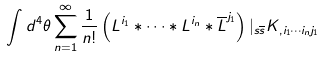<formula> <loc_0><loc_0><loc_500><loc_500>\int d ^ { 4 } \theta \sum _ { n = 1 } ^ { \infty } \frac { 1 } { n ! } \left ( L ^ { i _ { 1 } } \ast \dots \ast L ^ { i _ { n } } \ast \overline { L } ^ { j _ { 1 } } \right ) | _ { s \overline { s } } K _ { , i _ { 1 } \cdots i _ { n } j _ { 1 } }</formula> 